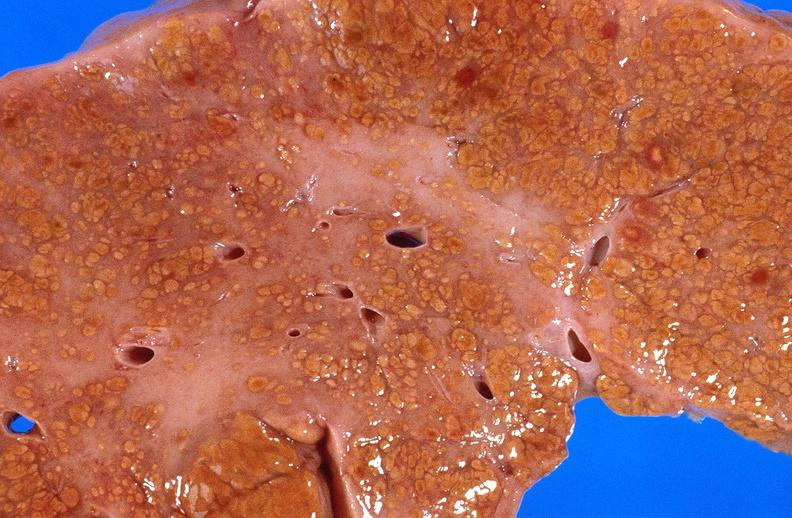s hepatobiliary present?
Answer the question using a single word or phrase. Yes 